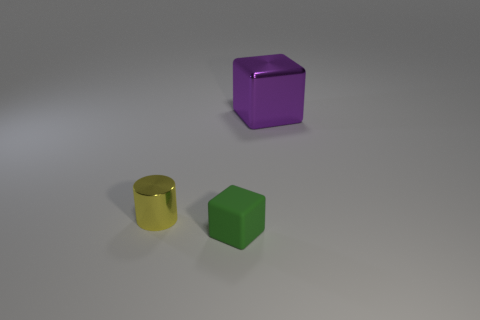Subtract all yellow cubes. Subtract all cyan cylinders. How many cubes are left? 2 Add 1 brown cylinders. How many objects exist? 4 Subtract all cylinders. How many objects are left? 2 Add 3 purple objects. How many purple objects are left? 4 Add 3 purple cubes. How many purple cubes exist? 4 Subtract 0 yellow spheres. How many objects are left? 3 Subtract all metal cylinders. Subtract all green cubes. How many objects are left? 1 